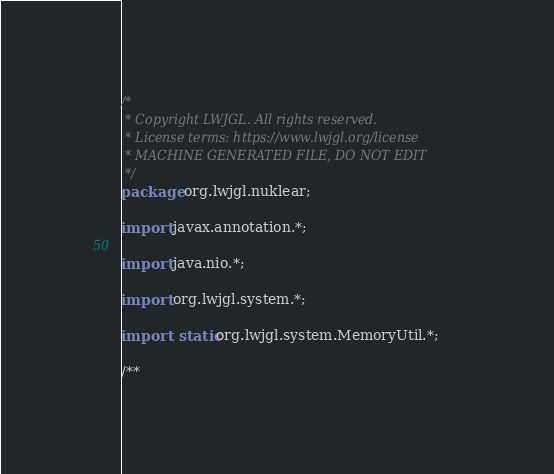Convert code to text. <code><loc_0><loc_0><loc_500><loc_500><_Java_>/*
 * Copyright LWJGL. All rights reserved.
 * License terms: https://www.lwjgl.org/license
 * MACHINE GENERATED FILE, DO NOT EDIT
 */
package org.lwjgl.nuklear;

import javax.annotation.*;

import java.nio.*;

import org.lwjgl.system.*;

import static org.lwjgl.system.MemoryUtil.*;

/**</code> 